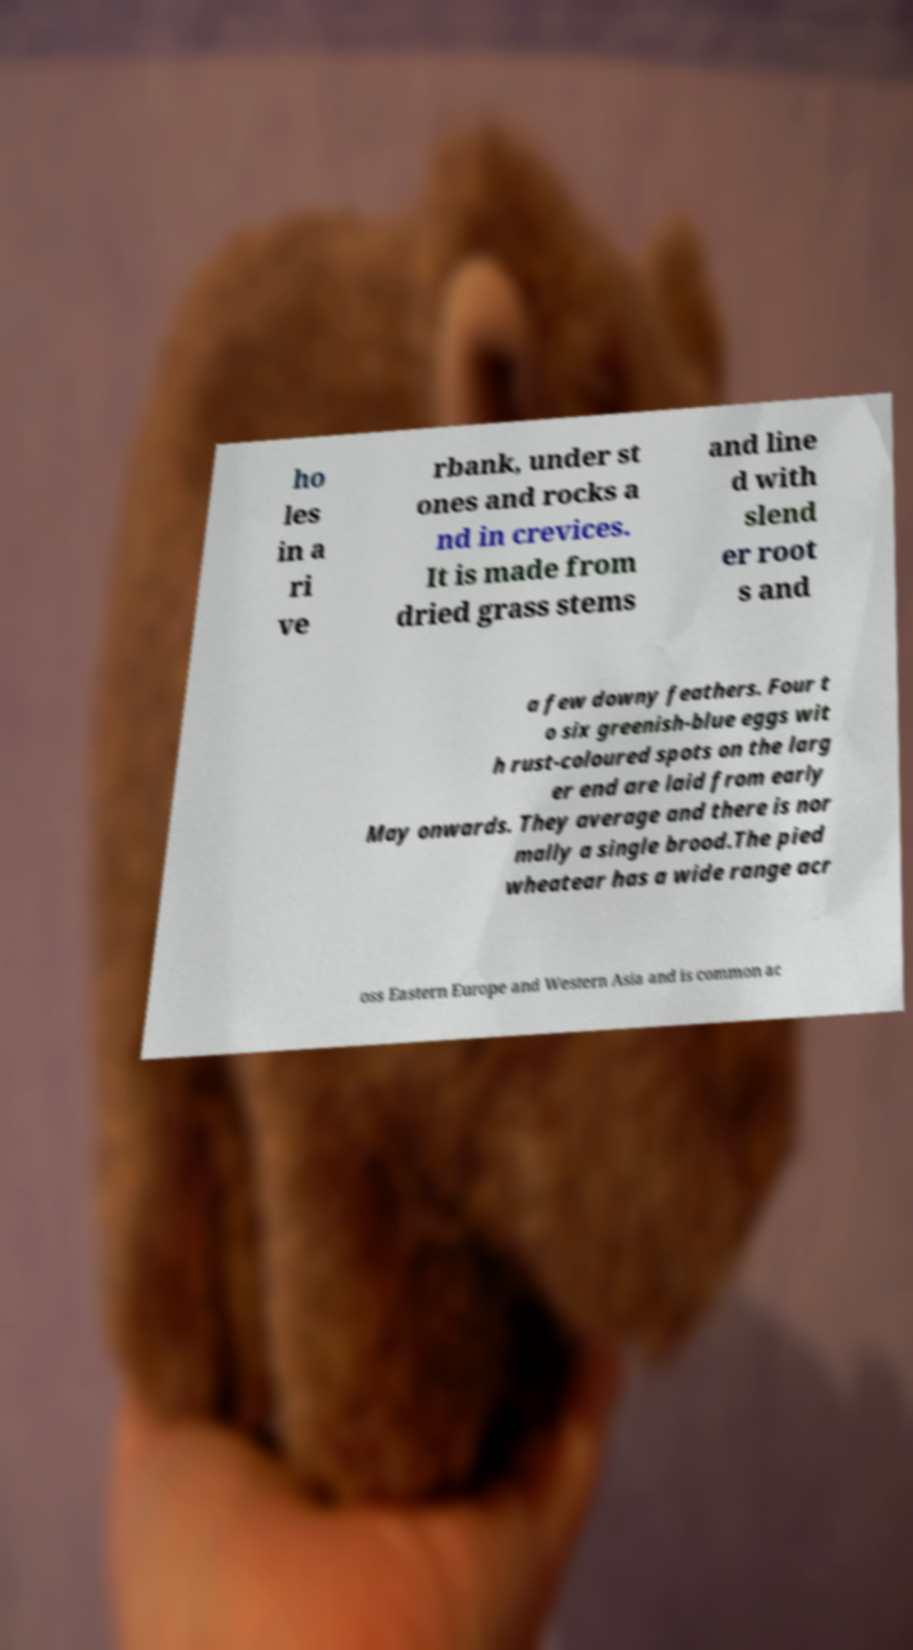What messages or text are displayed in this image? I need them in a readable, typed format. ho les in a ri ve rbank, under st ones and rocks a nd in crevices. It is made from dried grass stems and line d with slend er root s and a few downy feathers. Four t o six greenish-blue eggs wit h rust-coloured spots on the larg er end are laid from early May onwards. They average and there is nor mally a single brood.The pied wheatear has a wide range acr oss Eastern Europe and Western Asia and is common ac 